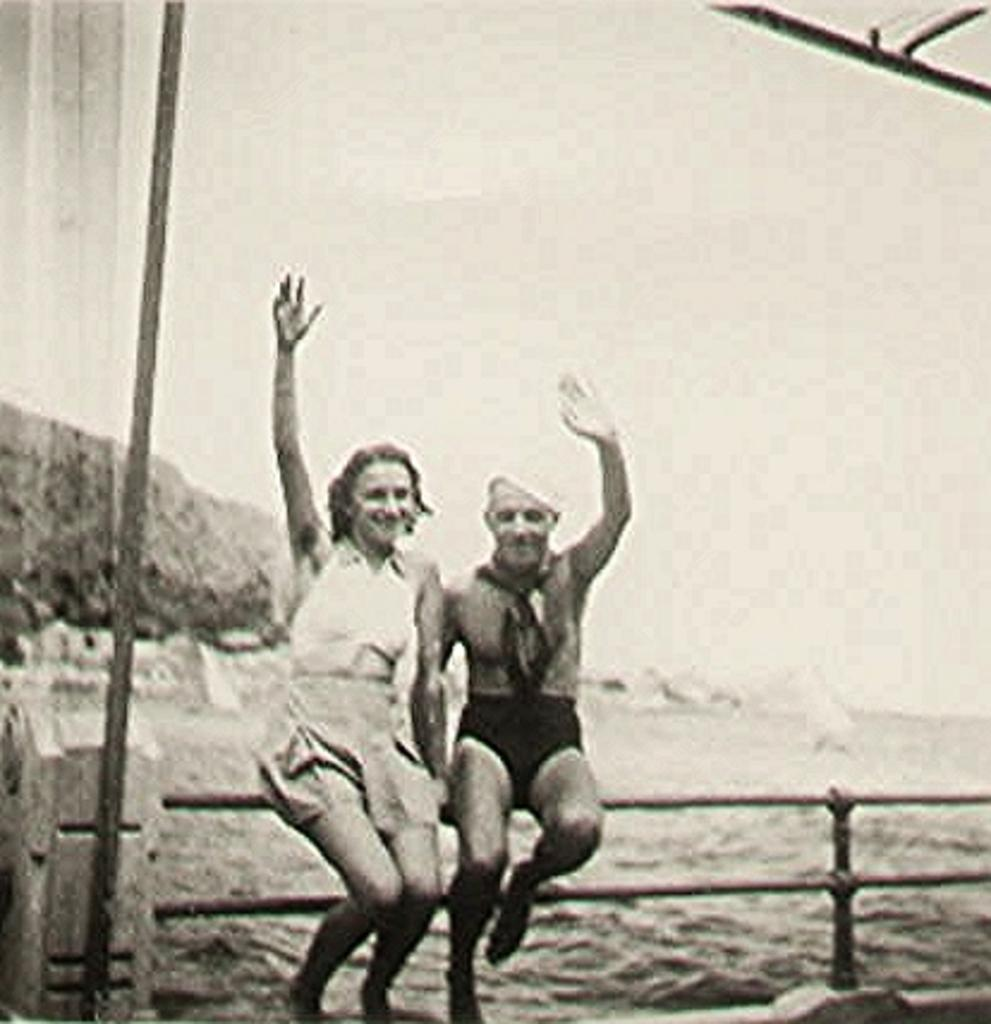What is the color scheme of the image? The image is black and white. What are the two people in the image doing? The two people are sitting on a fencing. What can be seen in the background of the image? There is water visible in the background of the image. What type of metal is the expert using to measure the yard in the image? There is no expert or metal measuring tool present in the image. 